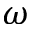<formula> <loc_0><loc_0><loc_500><loc_500>\omega</formula> 